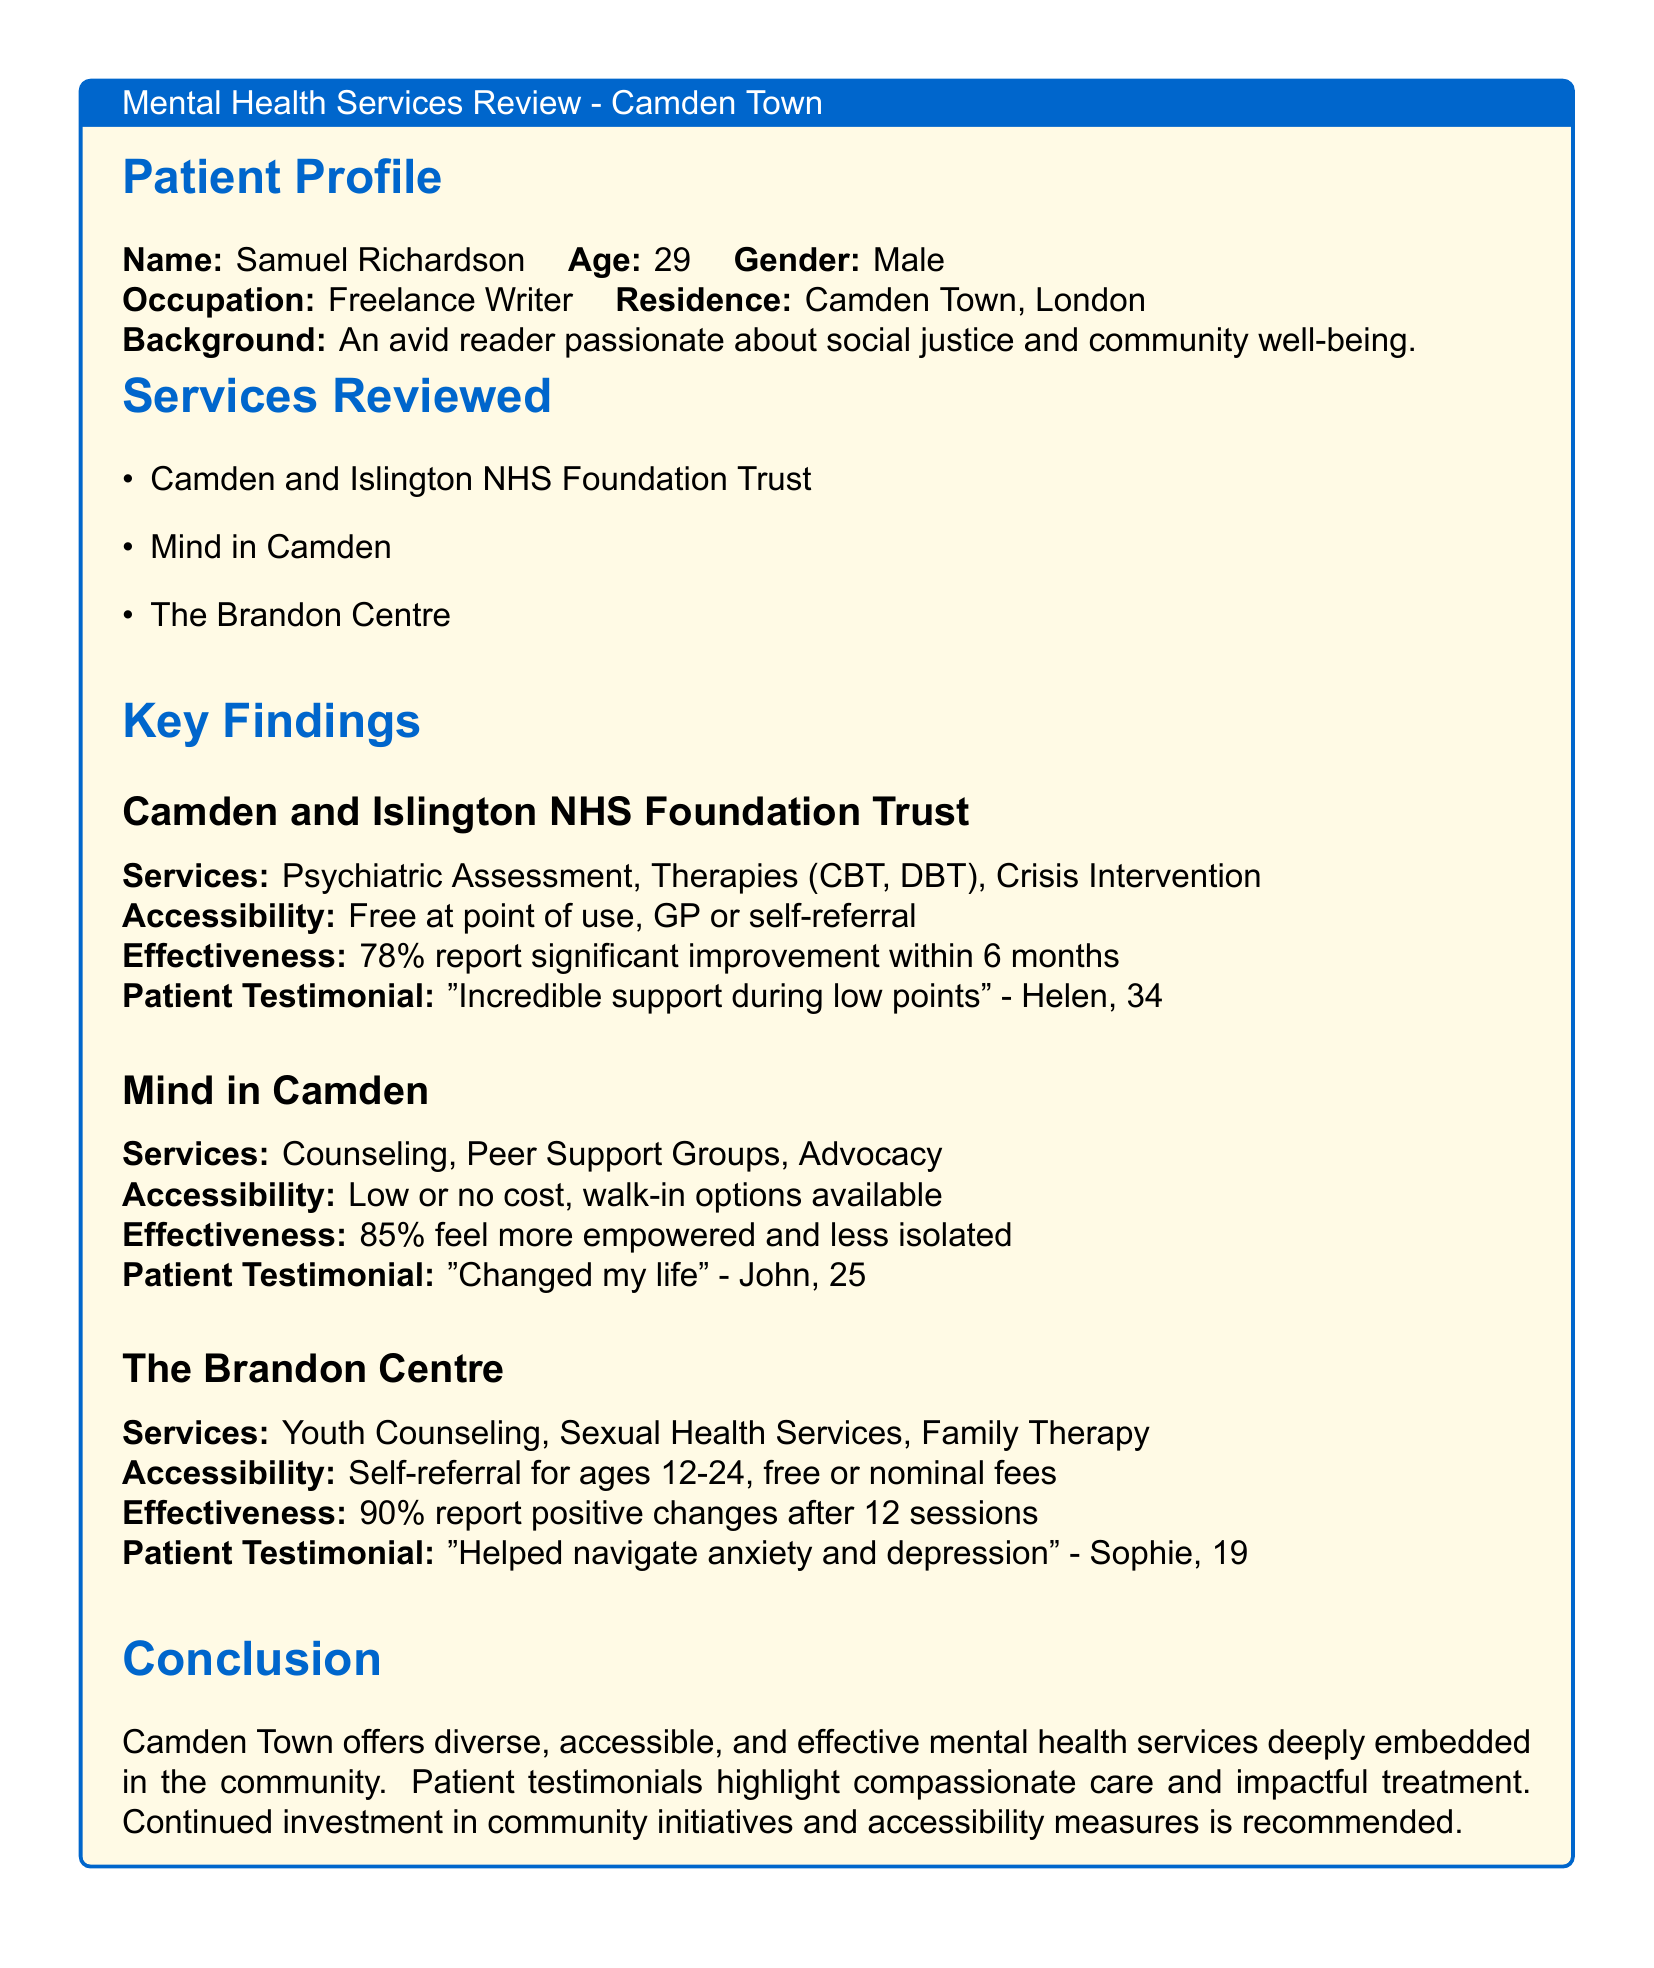What is the age of Samuel Richardson? Samuel Richardson's age is stated in the patient profile section of the document.
Answer: 29 What percentage of patients report significant improvement after 6 months at Camden and Islington NHS Foundation Trust? The effectiveness percentage is provided in the key findings section under Camden and Islington NHS Foundation Trust.
Answer: 78% Which organization provides youth counseling services? The relevant service is mentioned in the review of services and is specified under The Brandon Centre.
Answer: The Brandon Centre What is the primary accessibility feature for Mind in Camden services? The accessibility of services is described in the key findings section, specifically for Mind in Camden.
Answer: Low or no cost, walk-in options available What was John’s testimonial about? John’s testimonial, included under the Mind in Camden section, emphasizes the impact of the services provided.
Answer: "Changed my life" What type of therapy does the Camden and Islington NHS Foundation Trust offer? Specific services offered are listed as part of the key findings for this organization.
Answer: Therapies (CBT, DBT) What is the age range for self-referral at The Brandon Centre? The age limitations for self-referral to the services are detailed in the findings related to The Brandon Centre.
Answer: 12-24 What is the effectiveness rate reported for The Brandon Centre after 12 sessions? The percentage indicating effectiveness post-treatment is provided under the relevant organization.
Answer: 90% 